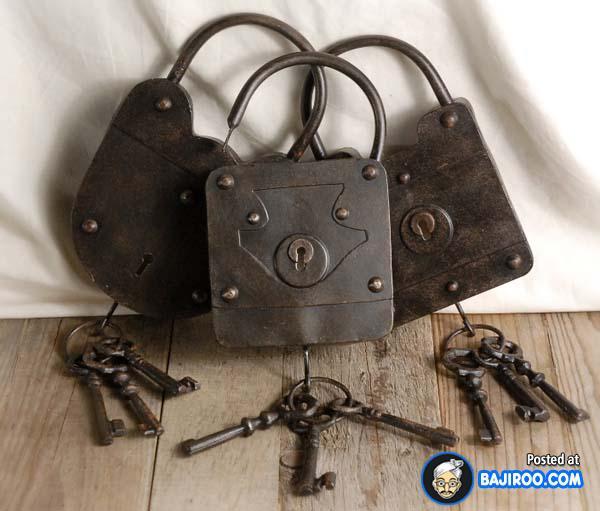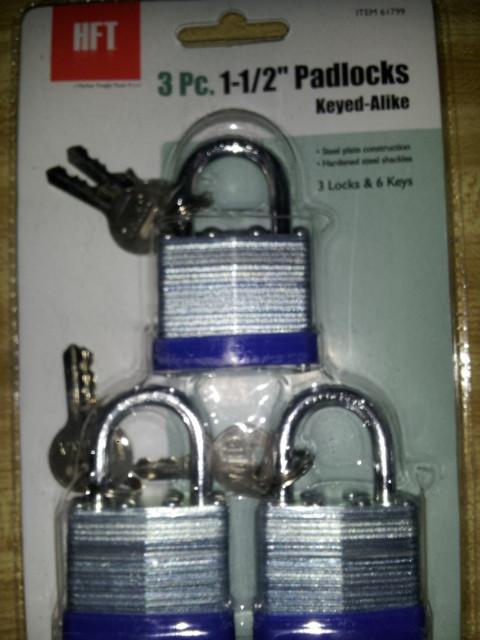The first image is the image on the left, the second image is the image on the right. Analyze the images presented: Is the assertion "there are newly never opened locks in packaging" valid? Answer yes or no. Yes. The first image is the image on the left, the second image is the image on the right. Given the left and right images, does the statement "The leftmost image contains exactly 3 tarnished old locks, not brand new or in packages." hold true? Answer yes or no. Yes. 